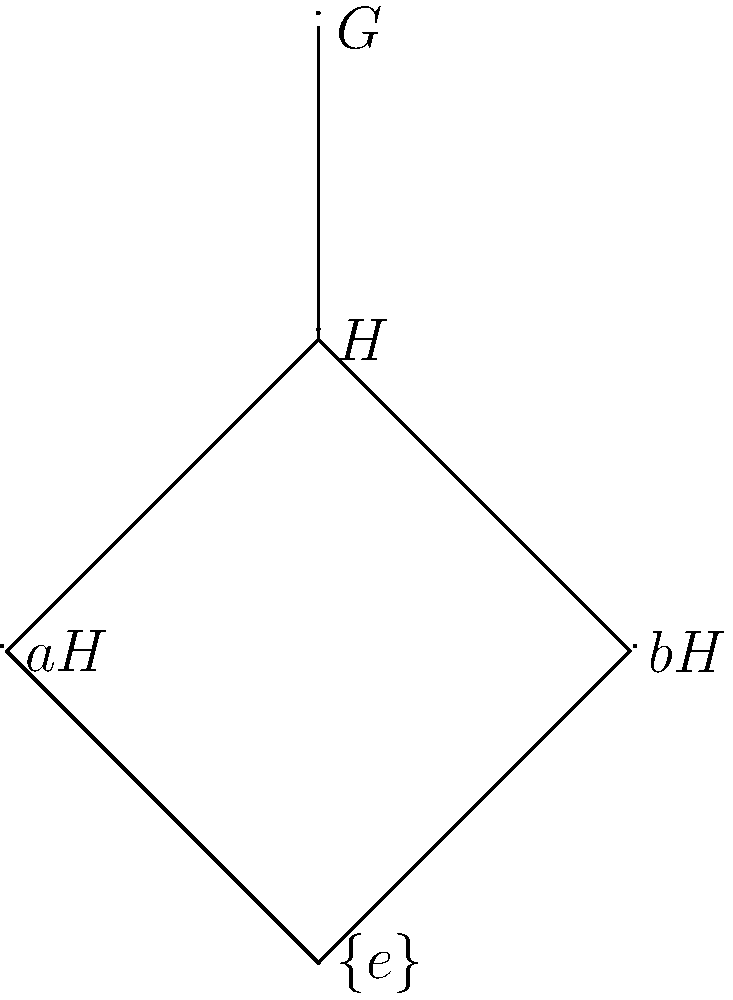In the given group lattice diagram, $H$ is a normal subgroup of $G$. If $|G| = 12$ and $|H| = 3$, how many distinct left cosets of $H$ are there in $G$, including $H$ itself? To determine the number of distinct left cosets of $H$ in $G$, we can follow these steps:

1) Recall the Lagrange's Theorem: For a finite group $G$ and a subgroup $H$, the order of $H$ divides the order of $G$, and the number of left cosets of $H$ in $G$ is equal to $[G:H] = \frac{|G|}{|H|}$.

2) We are given that $|G| = 12$ and $|H| = 3$.

3) Calculate $[G:H]$:
   $[G:H] = \frac{|G|}{|H|} = \frac{12}{3} = 4$

4) This means there are 4 distinct left cosets of $H$ in $G$.

5) We can verify this from the lattice diagram:
   - We see $H$ itself (which is always a coset)
   - We see two other cosets labeled $aH$ and $bH$
   - The fourth coset is $G$ itself, which contains all elements

Therefore, there are 4 distinct left cosets of $H$ in $G$, including $H$ itself.
Answer: 4 